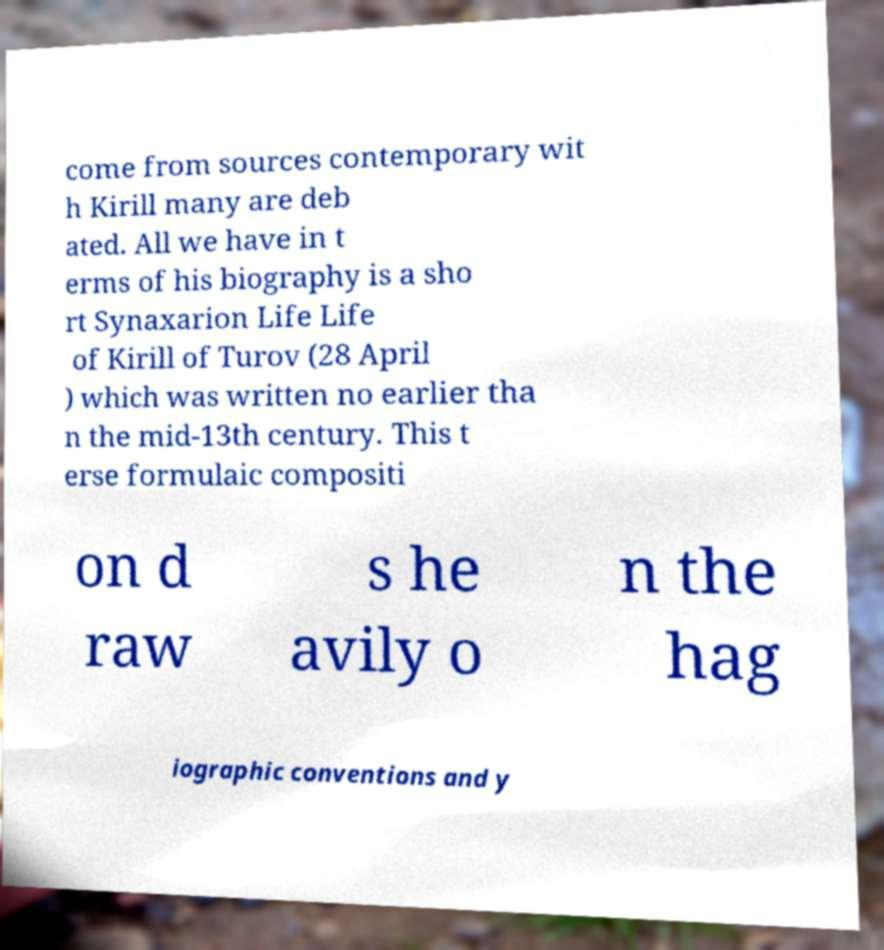Could you extract and type out the text from this image? come from sources contemporary wit h Kirill many are deb ated. All we have in t erms of his biography is a sho rt Synaxarion Life Life of Kirill of Turov (28 April ) which was written no earlier tha n the mid-13th century. This t erse formulaic compositi on d raw s he avily o n the hag iographic conventions and y 